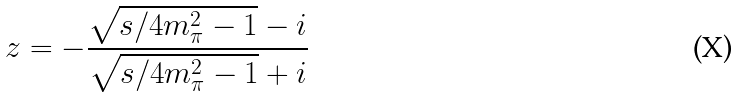<formula> <loc_0><loc_0><loc_500><loc_500>z = - \frac { \sqrt { s / 4 m ^ { 2 } _ { \pi } - 1 } - i } { \sqrt { s / 4 m ^ { 2 } _ { \pi } - 1 } + i }</formula> 